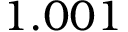Convert formula to latex. <formula><loc_0><loc_0><loc_500><loc_500>1 . 0 0 1</formula> 